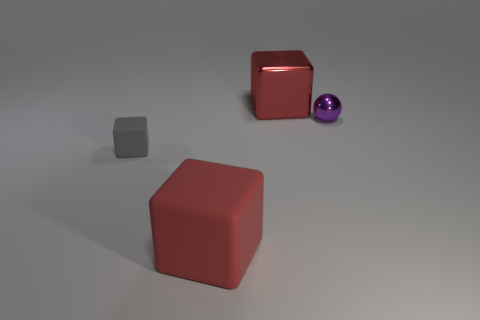How does the size of the gray cube compare to the purple sphere? The gray cube is relatively smaller than the purple sphere. While it's hard to determine the exact scale without reference, the sphere does seem to be slightly larger judging from the perspective in this image. 